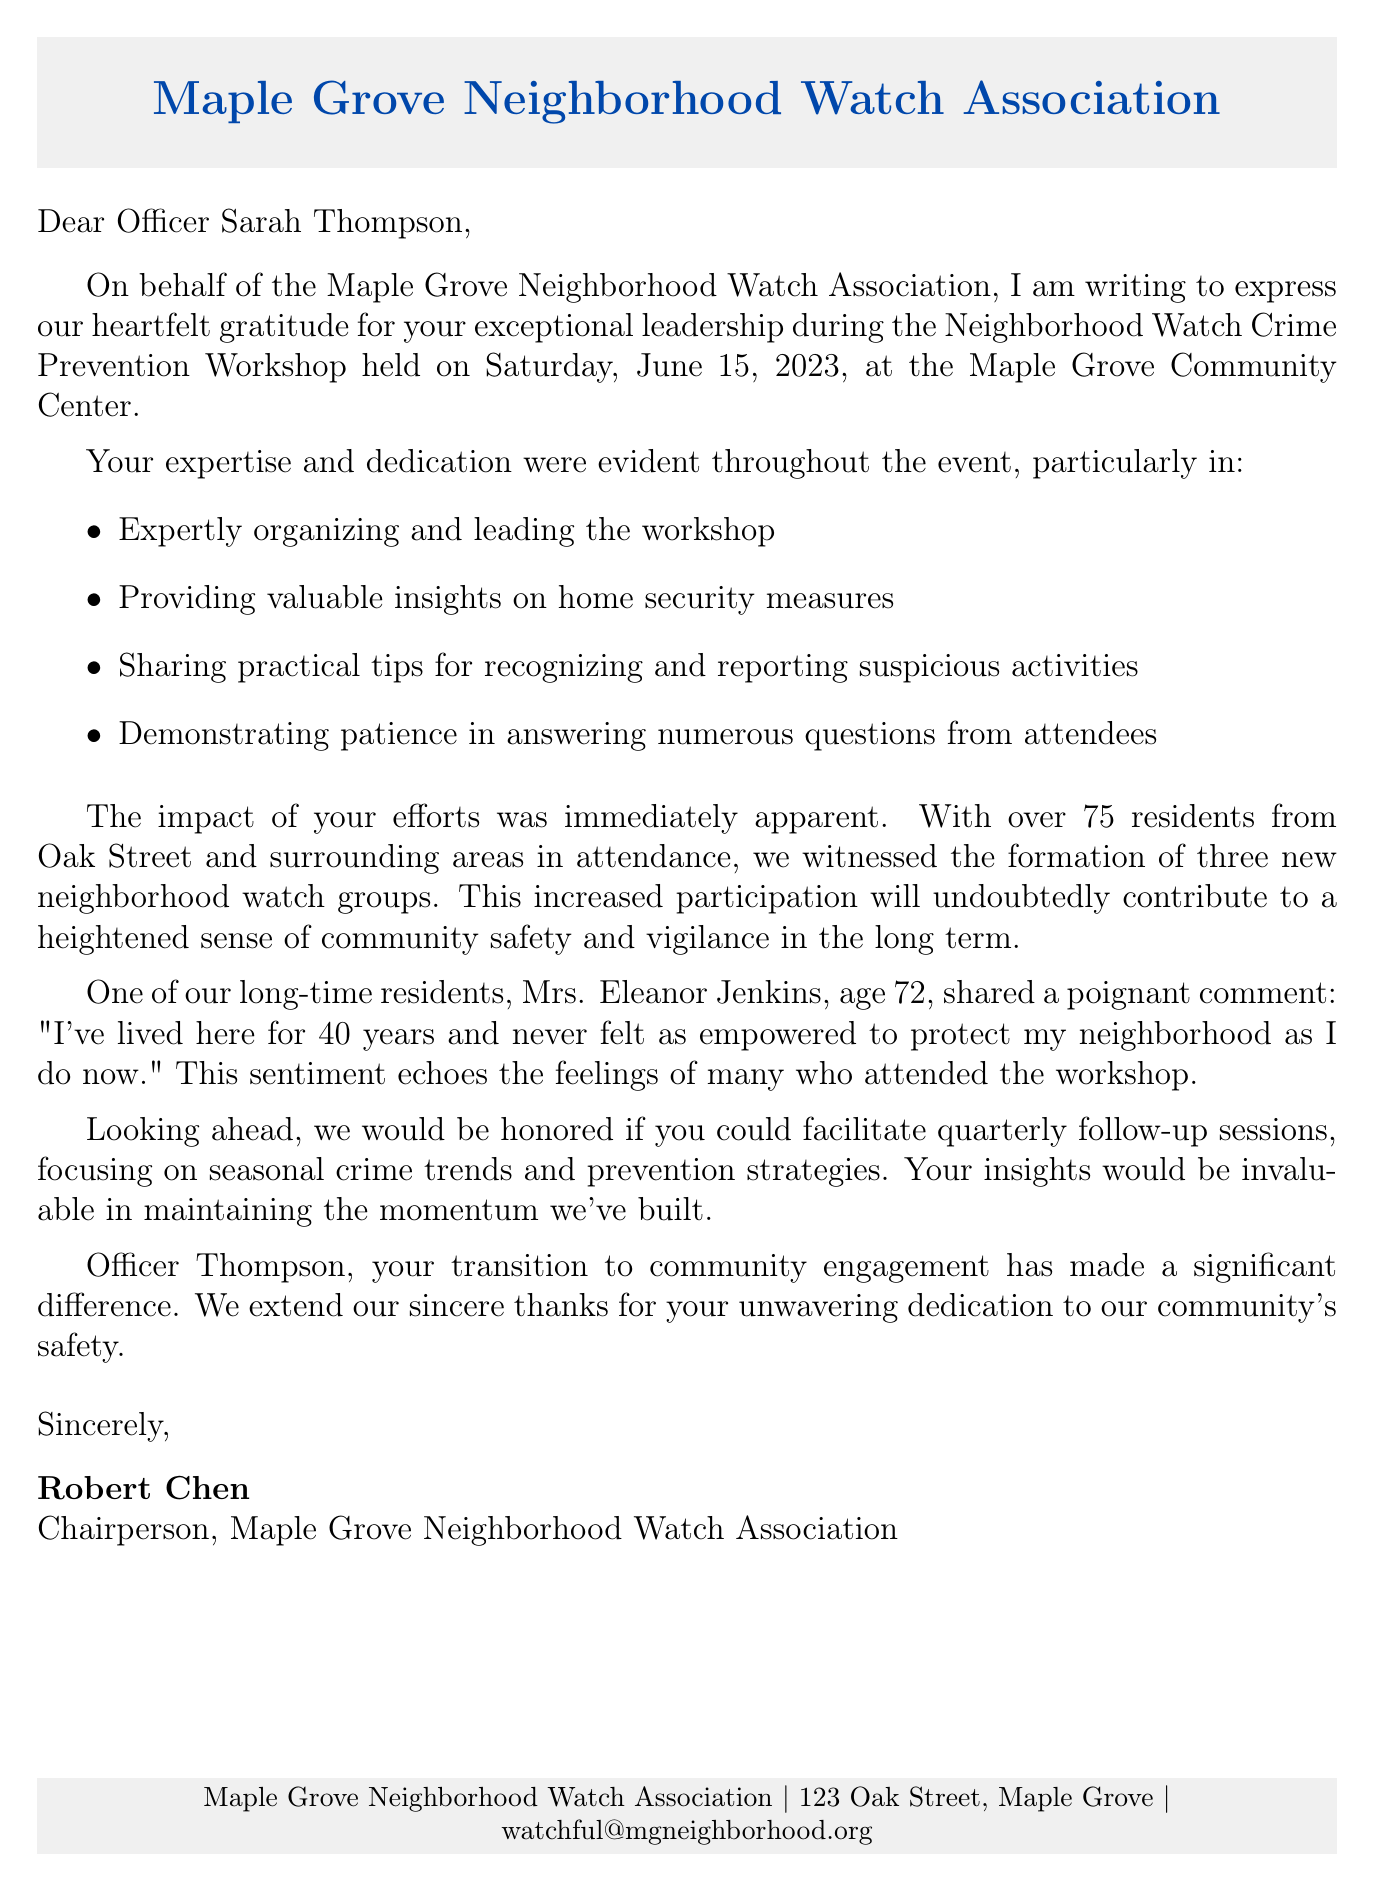What is the name of the officer addressed in the letter? The letter is addressed to Officer Sarah Thompson, as mentioned in the greeting.
Answer: Officer Sarah Thompson What was the date of the Neighborhood Watch Crime Prevention Workshop? The document states that the workshop was held on Saturday, June 15, 2023.
Answer: Saturday, June 15, 2023 How many residents attended the workshop? The document indicates that over 75 residents from Oak Street and surrounding areas attended the workshop.
Answer: Over 75 residents Who provided a notable comment about the workshop? The letter includes a comment from Mrs. Eleanor Jenkins that reflects her feelings about the workshop.
Answer: Mrs. Eleanor Jenkins What is the proposed topic for future collaboration? The letter mentions that the proposed topic for future sessions is seasonal crime trends and prevention strategies.
Answer: Seasonal crime trends and prevention strategies How many new neighborhood watch groups were formed as a result of the workshop? The document states that three new neighborhood watch groups were formed after the workshop.
Answer: Three new neighborhood watch groups Who signed the thank-you letter? The closing of the letter indicates that it was signed by Robert Chen, Chairperson of the Maple Grove Neighborhood Watch Association.
Answer: Robert Chen What was the main purpose of the letter? The primary purpose of the letter is to express gratitude for the officer's leadership during the workshop.
Answer: To express gratitude for the officer's leadership 